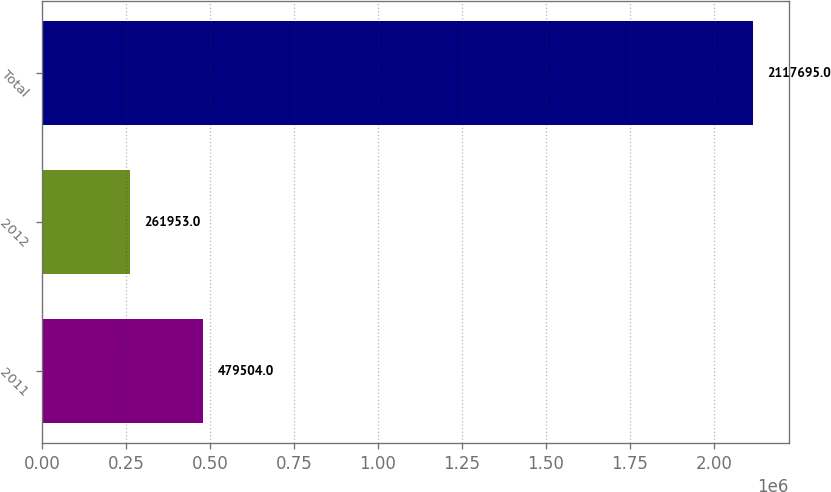Convert chart to OTSL. <chart><loc_0><loc_0><loc_500><loc_500><bar_chart><fcel>2011<fcel>2012<fcel>Total<nl><fcel>479504<fcel>261953<fcel>2.1177e+06<nl></chart> 